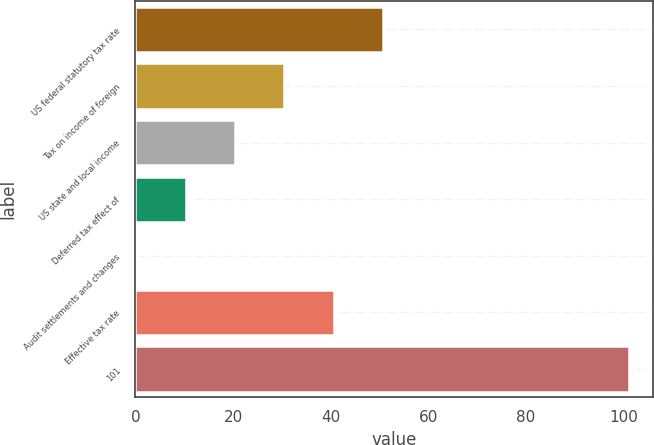Convert chart. <chart><loc_0><loc_0><loc_500><loc_500><bar_chart><fcel>US federal statutory tax rate<fcel>Tax on income of foreign<fcel>US state and local income<fcel>Deferred tax effect of<fcel>Audit settlements and changes<fcel>Effective tax rate<fcel>101<nl><fcel>50.65<fcel>30.51<fcel>20.44<fcel>10.37<fcel>0.3<fcel>40.58<fcel>101<nl></chart> 